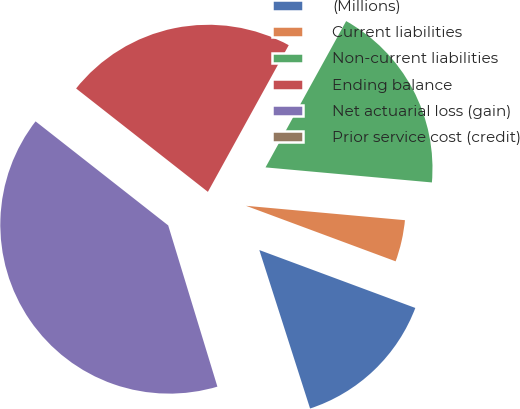Convert chart. <chart><loc_0><loc_0><loc_500><loc_500><pie_chart><fcel>(Millions)<fcel>Current liabilities<fcel>Non-current liabilities<fcel>Ending balance<fcel>Net actuarial loss (gain)<fcel>Prior service cost (credit)<nl><fcel>14.41%<fcel>4.22%<fcel>18.42%<fcel>22.43%<fcel>40.3%<fcel>0.22%<nl></chart> 